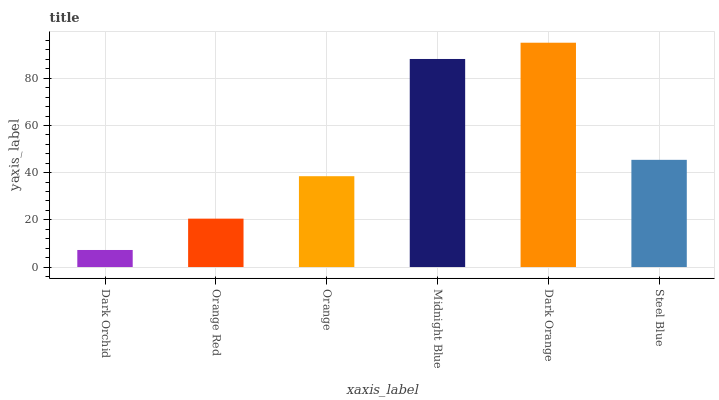Is Dark Orchid the minimum?
Answer yes or no. Yes. Is Dark Orange the maximum?
Answer yes or no. Yes. Is Orange Red the minimum?
Answer yes or no. No. Is Orange Red the maximum?
Answer yes or no. No. Is Orange Red greater than Dark Orchid?
Answer yes or no. Yes. Is Dark Orchid less than Orange Red?
Answer yes or no. Yes. Is Dark Orchid greater than Orange Red?
Answer yes or no. No. Is Orange Red less than Dark Orchid?
Answer yes or no. No. Is Steel Blue the high median?
Answer yes or no. Yes. Is Orange the low median?
Answer yes or no. Yes. Is Midnight Blue the high median?
Answer yes or no. No. Is Dark Orange the low median?
Answer yes or no. No. 